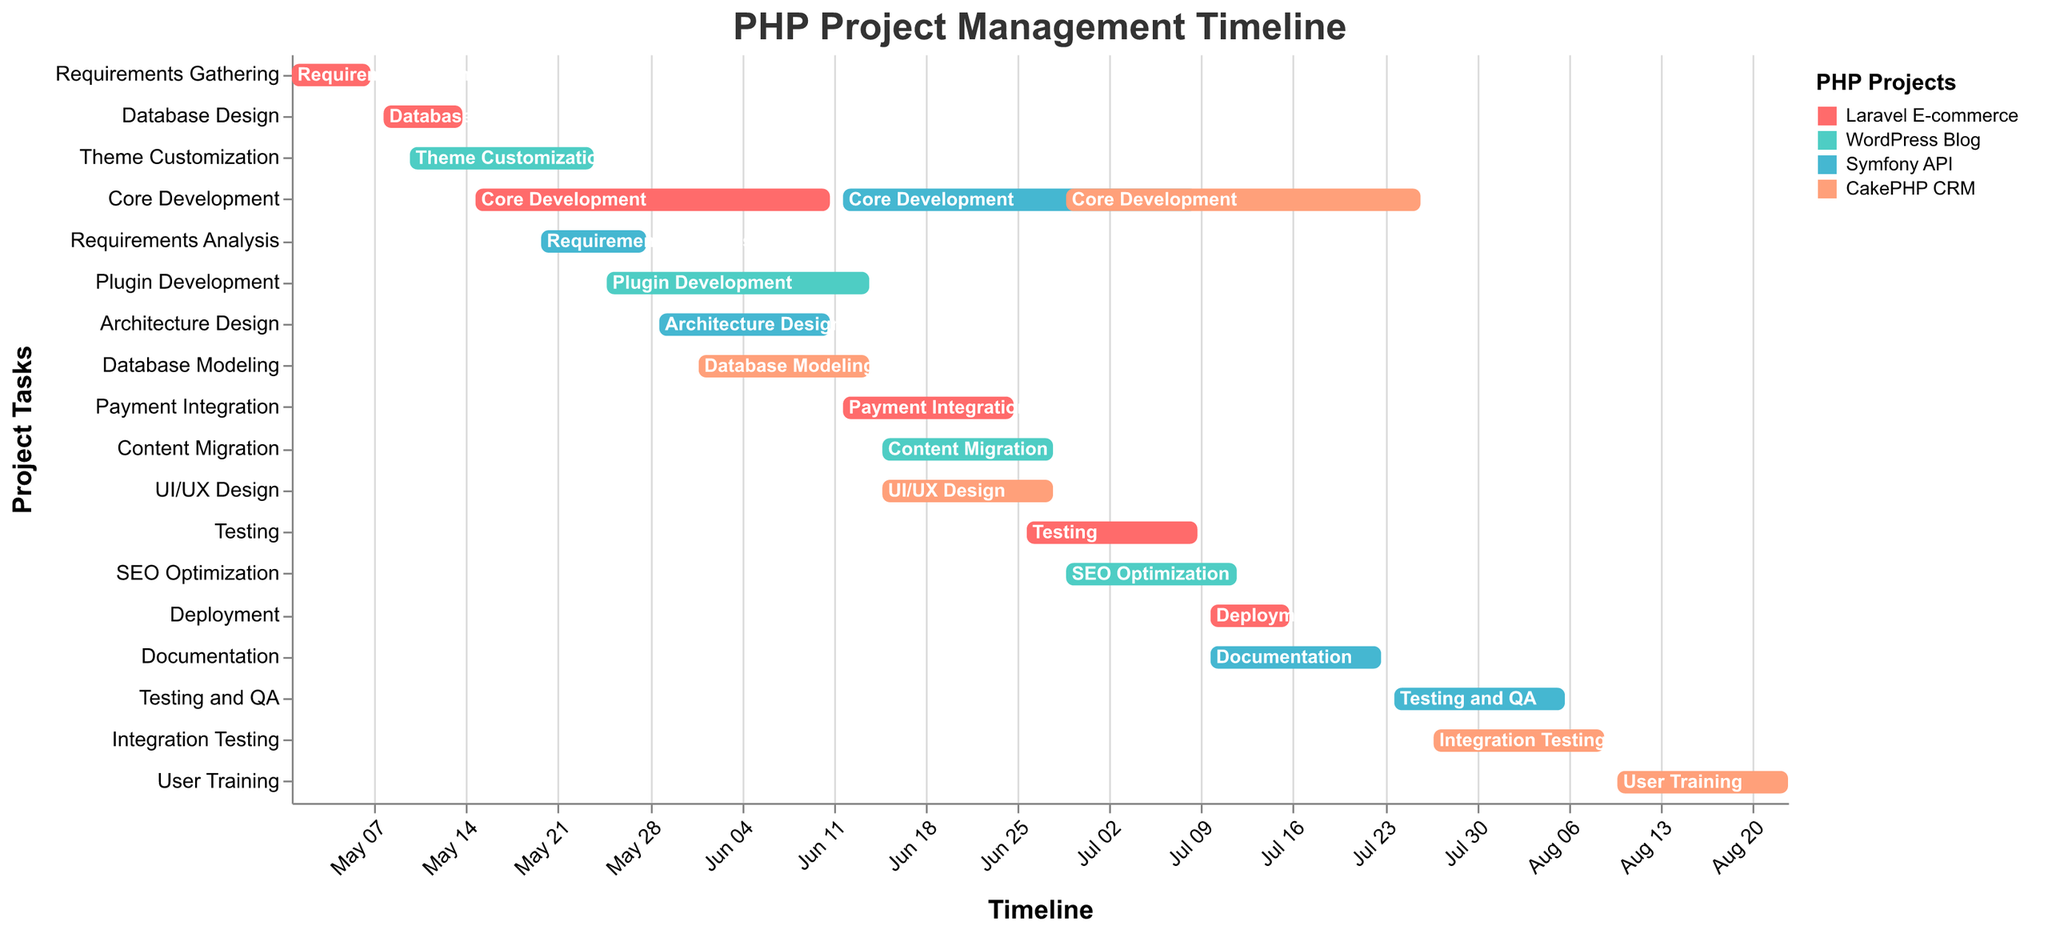When does the "Laravel E-commerce" project start and end? The "Laravel E-commerce" project starts with the "Requirements Gathering" task on May 1 and ends with the "Deployment" task on July 16. You can identify the start and end dates based on the timeline axis and the bars representing the tasks.
Answer: May 1 to July 16 Which project has the earliest start date, and what is it? By examining the start dates, the "Laravel E-commerce" project starts the earliest on May 1 with the "Requirements Gathering" task.
Answer: Laravel E-commerce, May 1 How many days does the "Core Development" task of the "Symfony API" project take? The "Core Development" task of the "Symfony API" project starts on June 12 and ends on July 9. The total number of days can be calculated by counting the days from June 12 to July 9, inclusive. There are 28 days in this range.
Answer: 28 days Which projects have overlapping development periods in June 2023? The "Laravel E-commerce," "WordPress Blog," "Symfony API," and "CakePHP CRM" projects all have tasks that overlap in June 2023, specifically the "Core Development" for Laravel E-commerce and Symfony API, "Plugin Development" and "Content Migration" for WordPress Blog, and "Database Modeling," "UI/UX Design," and "Core Development" for CakePHP CRM.
Answer: Laravel E-commerce, WordPress Blog, Symfony API, CakePHP CRM What is the total duration of the "CakePHP CRM" project's "Core Development" task? The "Core Development" task of the "CakePHP CRM" project runs from June 29 to July 26. The total duration can be calculated by counting the days from June 29 to July 26. Figure out the number of days in each month: 2 days in June (June 29 to June 30) and 26 days in July, leading to a total of 28 days for the task.
Answer: 28 days Compare the durations of the "Testing" tasks in "Laravel E-commerce" and "Symfony API" projects. Which one is longer and by how many days? The "Testing" task in the "Laravel E-commerce" project runs from June 26 to July 9, lasting 14 days. The "Testing and QA" task in the "Symfony API" project runs from July 24 to August 6, also lasting 14 days. Therefore, the durations are equal.
Answer: Equal durations During which period does the "WordPress Blog" project specifically work on "Plugin Development"? The "Plugin Development" task for the "WordPress Blog" project occurs between May 25 and June 14, as indicated by the position and duration of the corresponding bar.
Answer: May 25 to June 14 How many tasks are scheduled for the "Symfony API" project, and what are they? The "Symfony API" project has 5 tasks: "Requirements Analysis," "Architecture Design," "Core Development," "Documentation," and "Testing and QA." Each task can be identified by locating the project name and its associated tasks in the chart.
Answer: 5 tasks: Requirements Analysis, Architecture Design, Core Development, Documentation, Testing and QA 